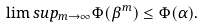<formula> <loc_0><loc_0><loc_500><loc_500>\lim s u p _ { m \to \infty } \Phi ( \beta ^ { m } ) \leq \Phi ( \alpha ) .</formula> 